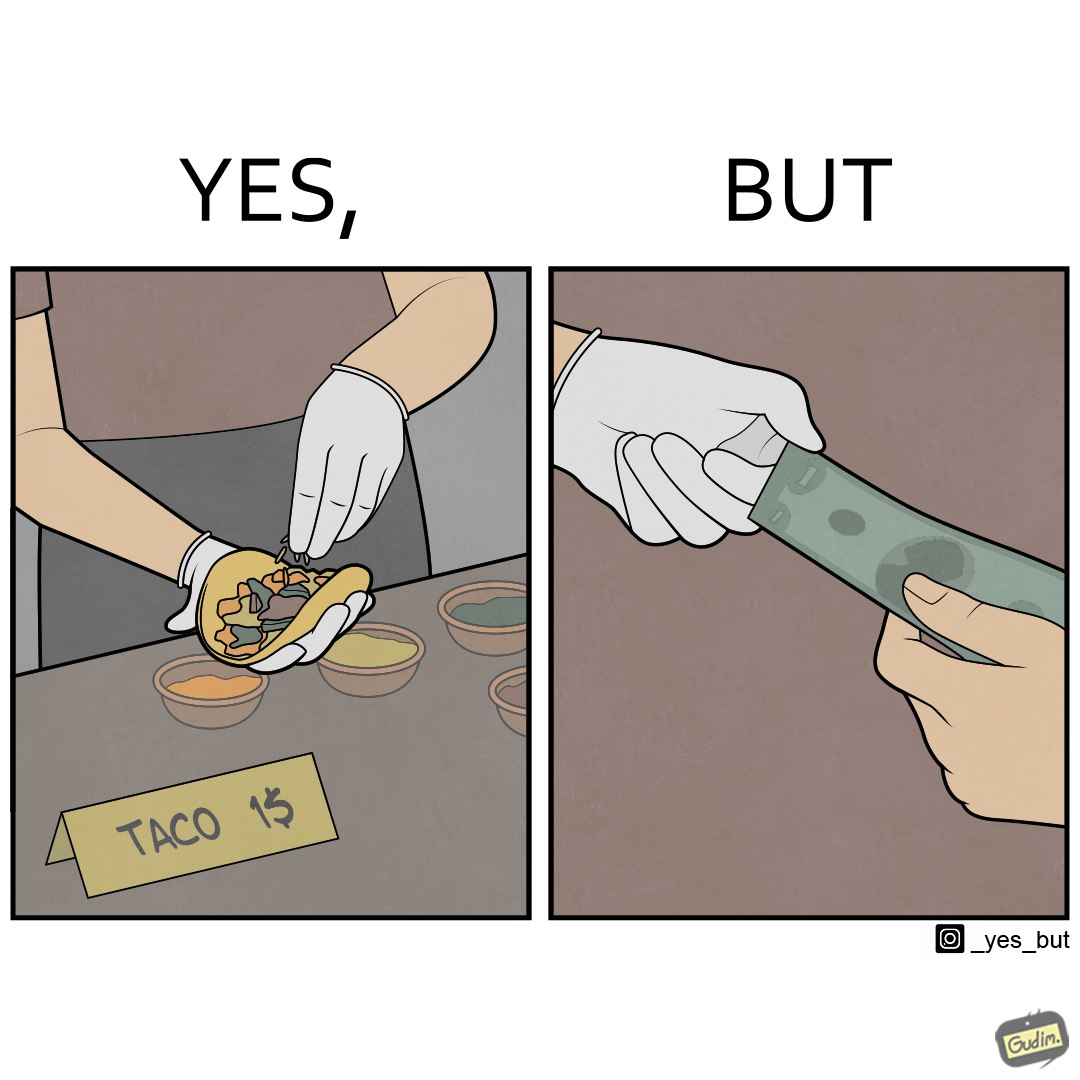Describe what you see in this image. The image is satirical because the intention of wearing a glove while preparing food is to not let any germs and dirt from our hands get into the food, people do other tasks like collecting money from the customer wearing the same gloves and thus making the gloves themselves dirty. 